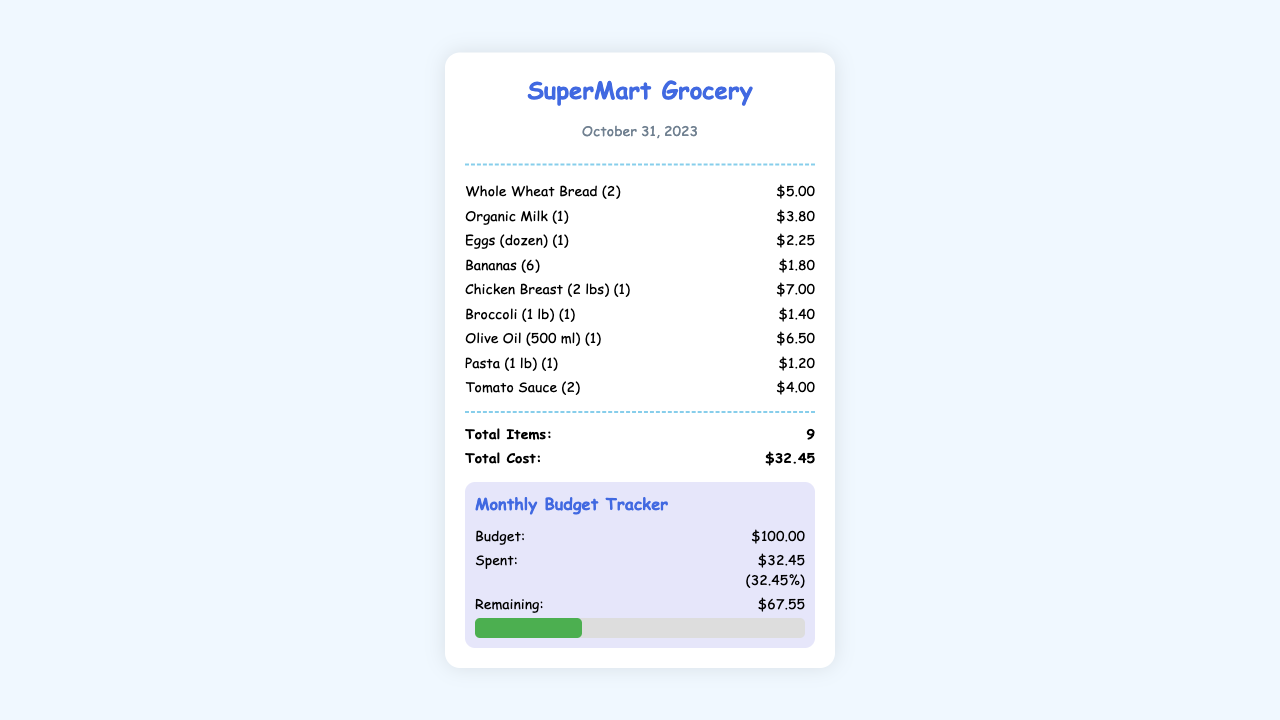What is the date of the receipt? The date of the receipt is displayed in the header section, which states October 31, 2023.
Answer: October 31, 2023 What is the total cost of the items purchased? The total cost is summarized at the bottom of the receipt, showing $32.45.
Answer: $32.45 How many items were bought? The receipt states the total number of items, which is 9.
Answer: 9 What is the budget for the month? The budget is mentioned in the monthly budget tracker section, which lists $100.00.
Answer: $100.00 How much money is remaining after the purchase? The remaining amount is displayed in the spending habits section, which indicates $67.55.
Answer: $67.55 What percentage of the budget has been spent? The spent amount percentage is shown next to the spent total, which states 32.45%.
Answer: 32.45% What is the name of the store? The name of the store is found at the top of the receipt, which shows SuperMart Grocery.
Answer: SuperMart Grocery What type of item is Broccoli? The item is categorized as a vegetable, displayed as Broccoli (1 lb) (1).
Answer: Vegetable How many chicken breasts were purchased? The receipt shows the purchase as Chicken Breast (2 lbs) (1), indicating the quantity.
Answer: 1 